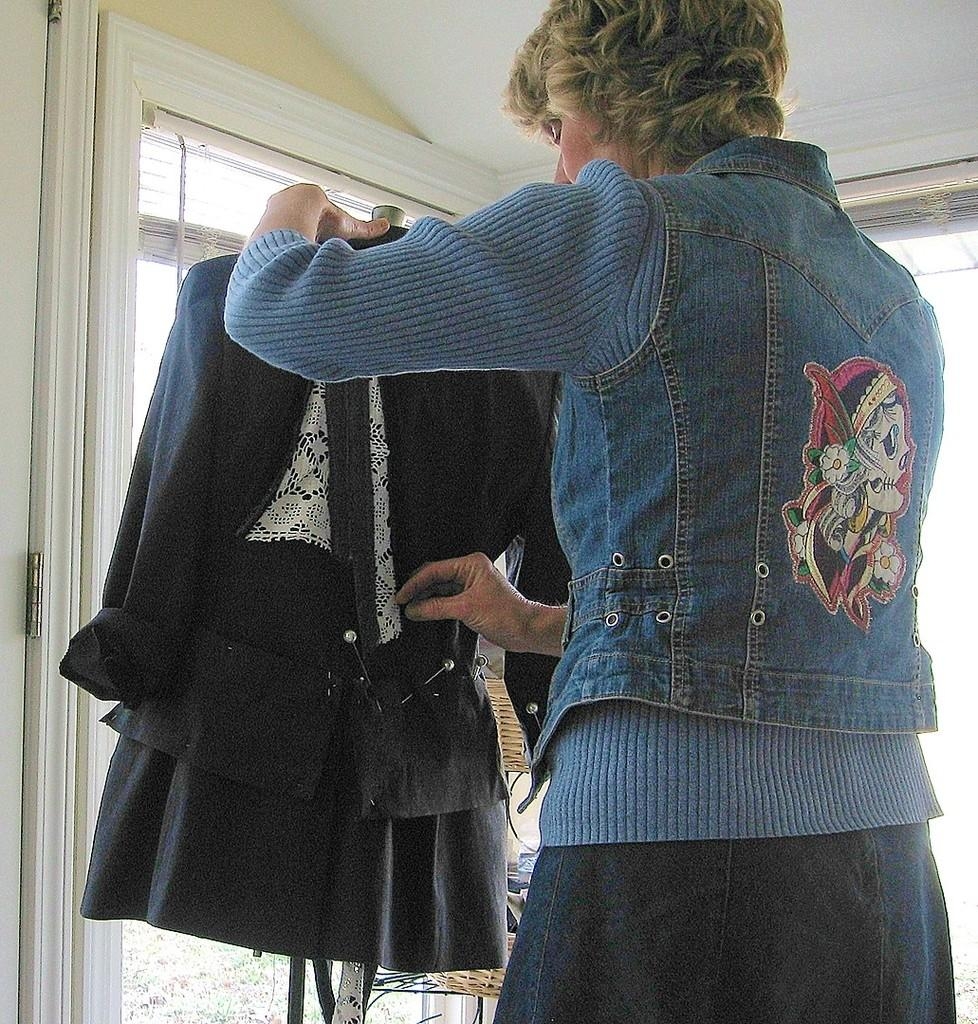Who or what is present in the image? There is a person in the image. What is the person holding? The person is holding a dress. What can be seen in the background of the image? There is a door visible in the background of the image. What type of band is playing in the background of the image? There is no band present in the image; it only features a person holding a dress and a door in the background. 